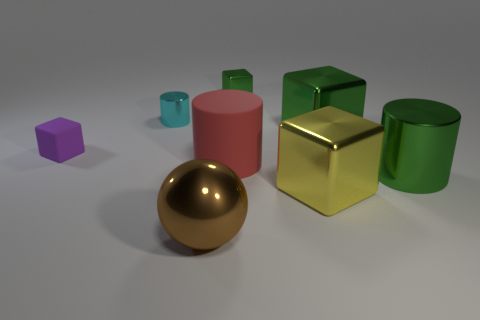How many objects in the image have a reflective surface? There are a total of four objects with reflective surfaces in the image: the golden sphere, the small metallic cube, the large green cylinder, and the taller purple cylinder. 